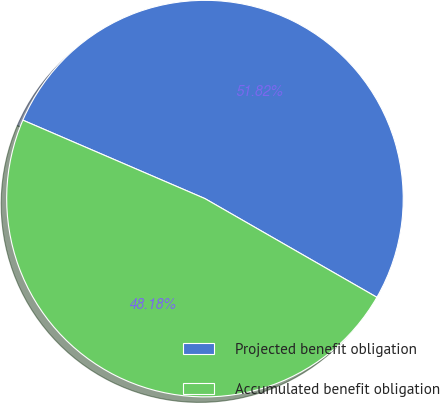<chart> <loc_0><loc_0><loc_500><loc_500><pie_chart><fcel>Projected benefit obligation<fcel>Accumulated benefit obligation<nl><fcel>51.82%<fcel>48.18%<nl></chart> 